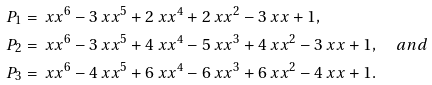<formula> <loc_0><loc_0><loc_500><loc_500>P _ { 1 } & = \ x x ^ { 6 } - 3 \ x x ^ { 5 } + 2 \ x x ^ { 4 } + 2 \ x x ^ { 2 } - 3 \ x x + 1 , \\ P _ { 2 } & = \ x x ^ { 6 } - 3 \ x x ^ { 5 } + 4 \ x x ^ { 4 } - 5 \ x x ^ { 3 } + 4 \ x x ^ { 2 } - 3 \ x x + 1 , \quad a n d \\ P _ { 3 } & = \ x x ^ { 6 } - 4 \ x x ^ { 5 } + 6 \ x x ^ { 4 } - 6 \ x x ^ { 3 } + 6 \ x x ^ { 2 } - 4 \ x x + 1 .</formula> 